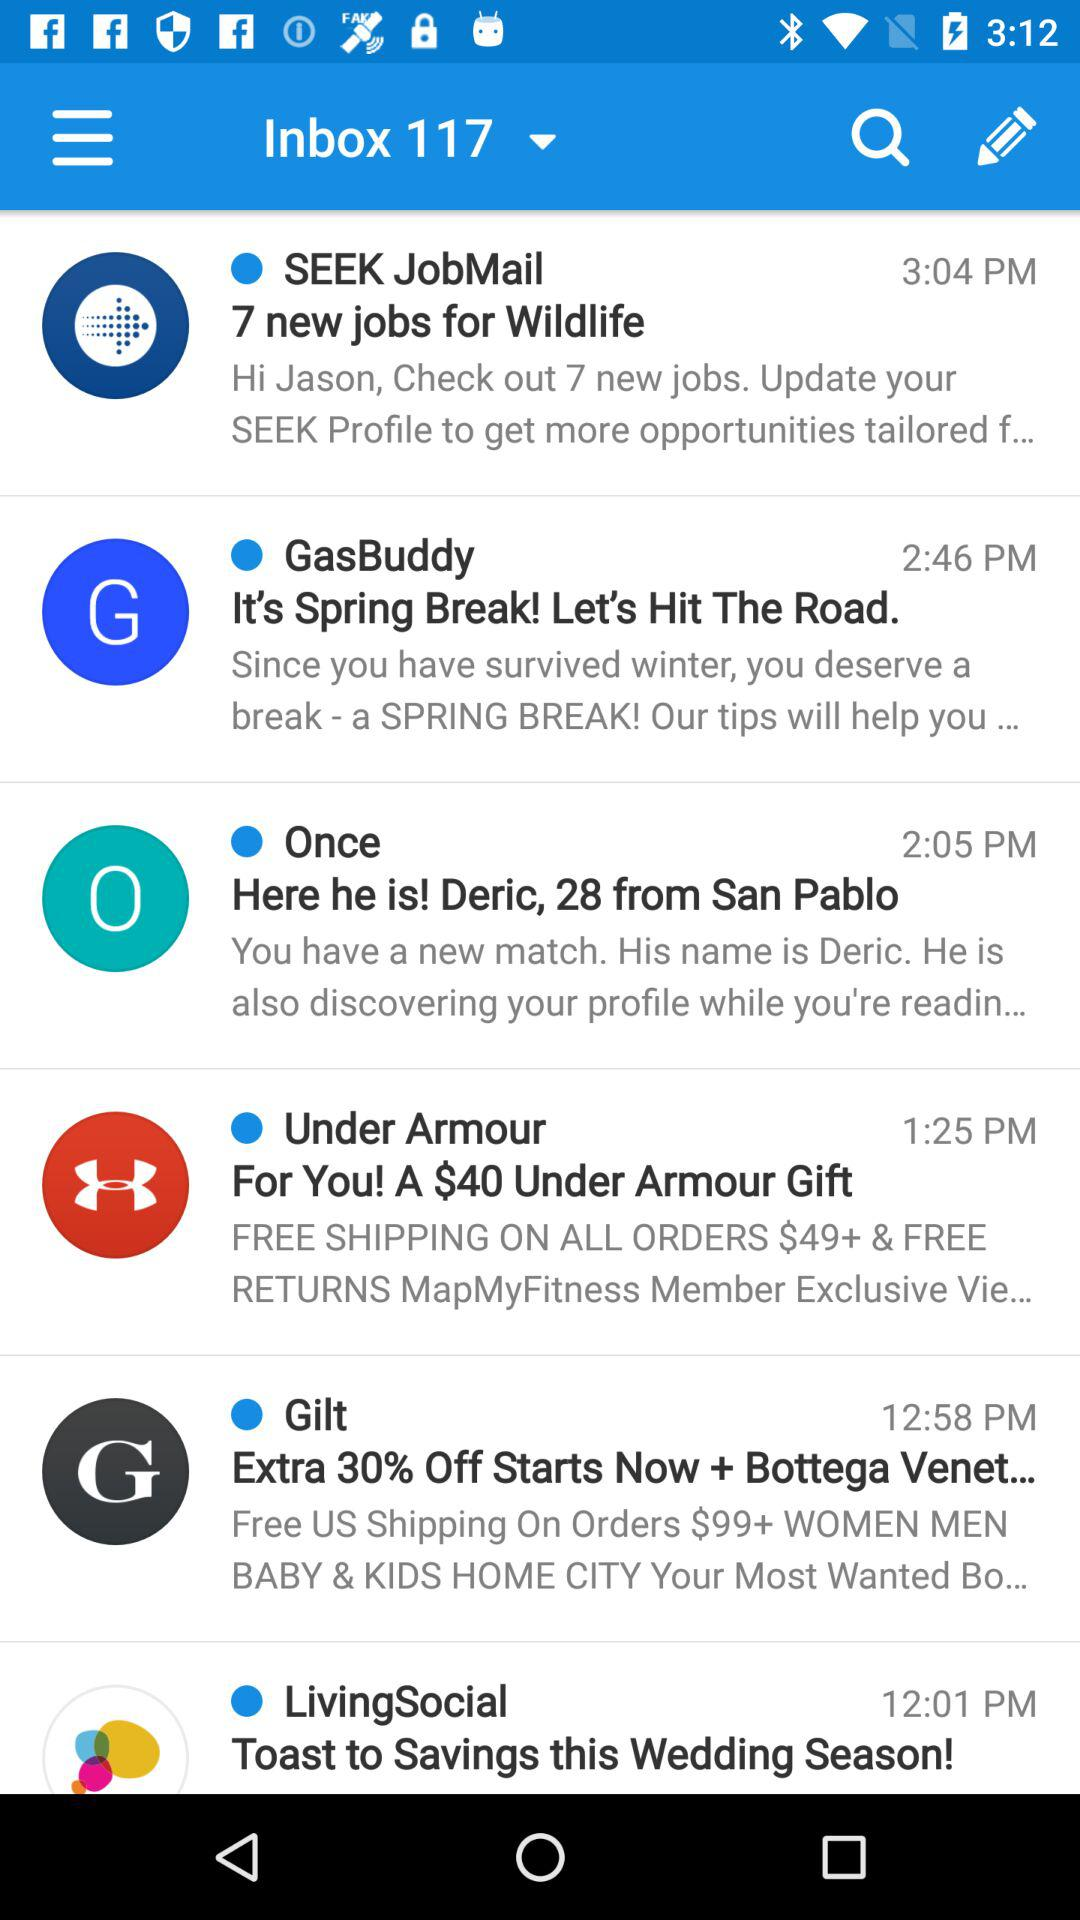How many items are in the inbox?
Answer the question using a single word or phrase. 6 